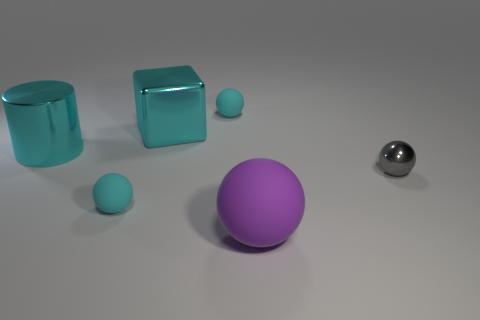Subtract 1 spheres. How many spheres are left? 3 Add 1 small gray matte cylinders. How many objects exist? 7 Subtract all cylinders. How many objects are left? 5 Subtract 0 blue blocks. How many objects are left? 6 Subtract all small balls. Subtract all large cyan shiny objects. How many objects are left? 1 Add 4 tiny cyan balls. How many tiny cyan balls are left? 6 Add 1 large metal cubes. How many large metal cubes exist? 2 